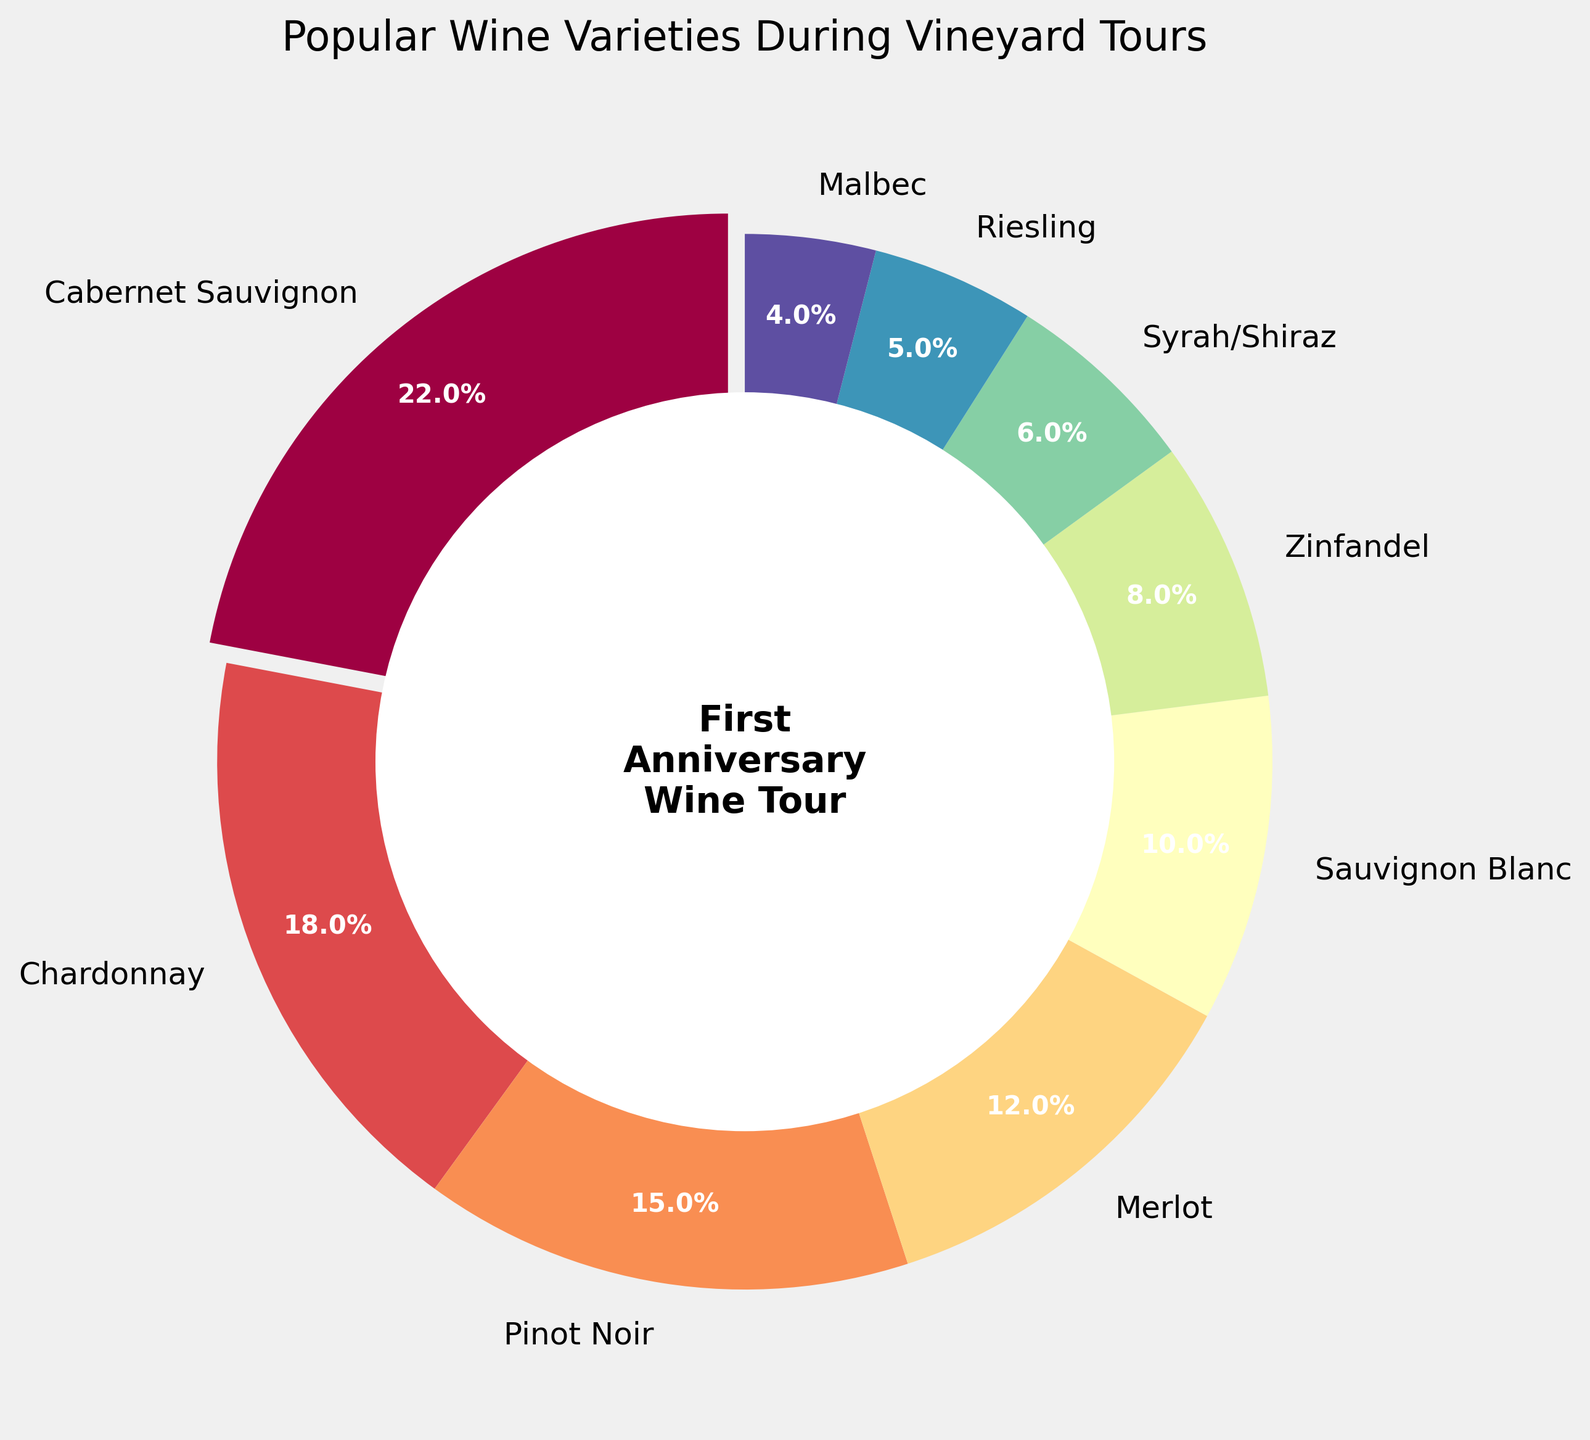Which wine variety is the most popular during vineyard tours? The pie chart shows the percentages of various wine varieties consumed. The largest slice of the pie represents the most popular wine variety. In this case, it's labeled "Cabernet Sauvignon" with 22%.
Answer: Cabernet Sauvignon Which wine variety is the least popular during vineyard tours? The smallest slice of the pie chart indicates the least popular wine variety, which is labeled "Malbec" with 4%.
Answer: Malbec How do the percentages of Chardonnay and Pinot Noir compare? The percentages for Chardonnay and Pinot Noir can be directly read from the chart. Chardonnay has 18%, and Pinot Noir has 15%. Therefore, Chardonnay has a higher percentage than Pinot Noir.
Answer: Chardonnay has a higher percentage What is the combined percentage of Zinfandel and Syrah/Shiraz? The chart shows Zinfandel at 8% and Syrah/Shiraz at 6%. Adding these two percentages: 8% + 6% = 14%.
Answer: 14% If we combine the percentages of the three least popular varieties (Syrah/Shiraz, Riesling, and Malbec), what is their total percentage? The chart shows Syrah/Shiraz at 6%, Riesling at 5%, and Malbec at 4%. Adding these three percentages: 6% + 5% + 4% = 15%.
Answer: 15% Which white wine variety has the higher percentage: Chardonnay or Sauvignon Blanc? The chart shows Chardonnay at 18% and Sauvignon Blanc at 10%. Thus, Chardonnay has a higher percentage than Sauvignon Blanc.
Answer: Chardonnay What is the difference in percentage between Cabernet Sauvignon and Merlot? The chart shows Cabernet Sauvignon at 22% and Merlot at 12%. The difference is calculated as follows: 22% - 12% = 10%.
Answer: 10% If you wanted to try half of the listed wine varieties, what would be the total percentage of the top 4 varieties? The top four varieties from the chart are Cabernet Sauvignon (22%), Chardonnay (18%), Pinot Noir (15%), and Merlot (12%). Adding these percentages: 22% + 18% + 15% + 12% = 67%.
Answer: 67% Which wine varieties have a lower percentage than Syrah/Shiraz? The chart shows Syrah/Shiraz at 6%. The quantities lower than 6% are Riesling (5%) and Malbec (4%).
Answer: Riesling and Malbec 